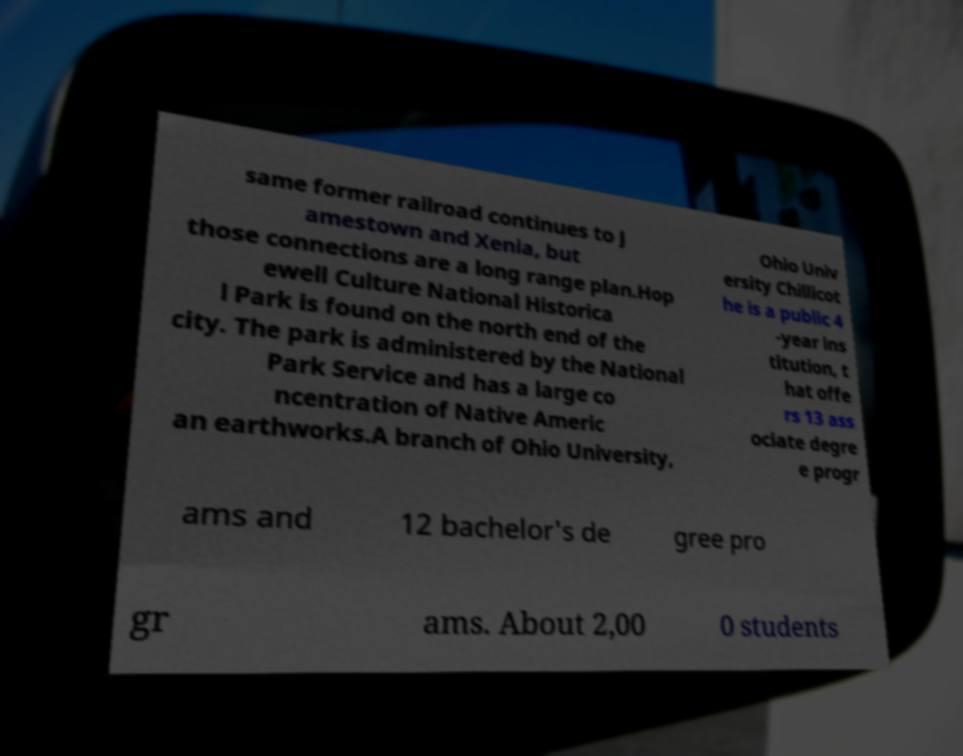Could you extract and type out the text from this image? same former railroad continues to J amestown and Xenia, but those connections are a long range plan.Hop ewell Culture National Historica l Park is found on the north end of the city. The park is administered by the National Park Service and has a large co ncentration of Native Americ an earthworks.A branch of Ohio University, Ohio Univ ersity Chillicot he is a public 4 -year ins titution, t hat offe rs 13 ass ociate degre e progr ams and 12 bachelor's de gree pro gr ams. About 2,00 0 students 